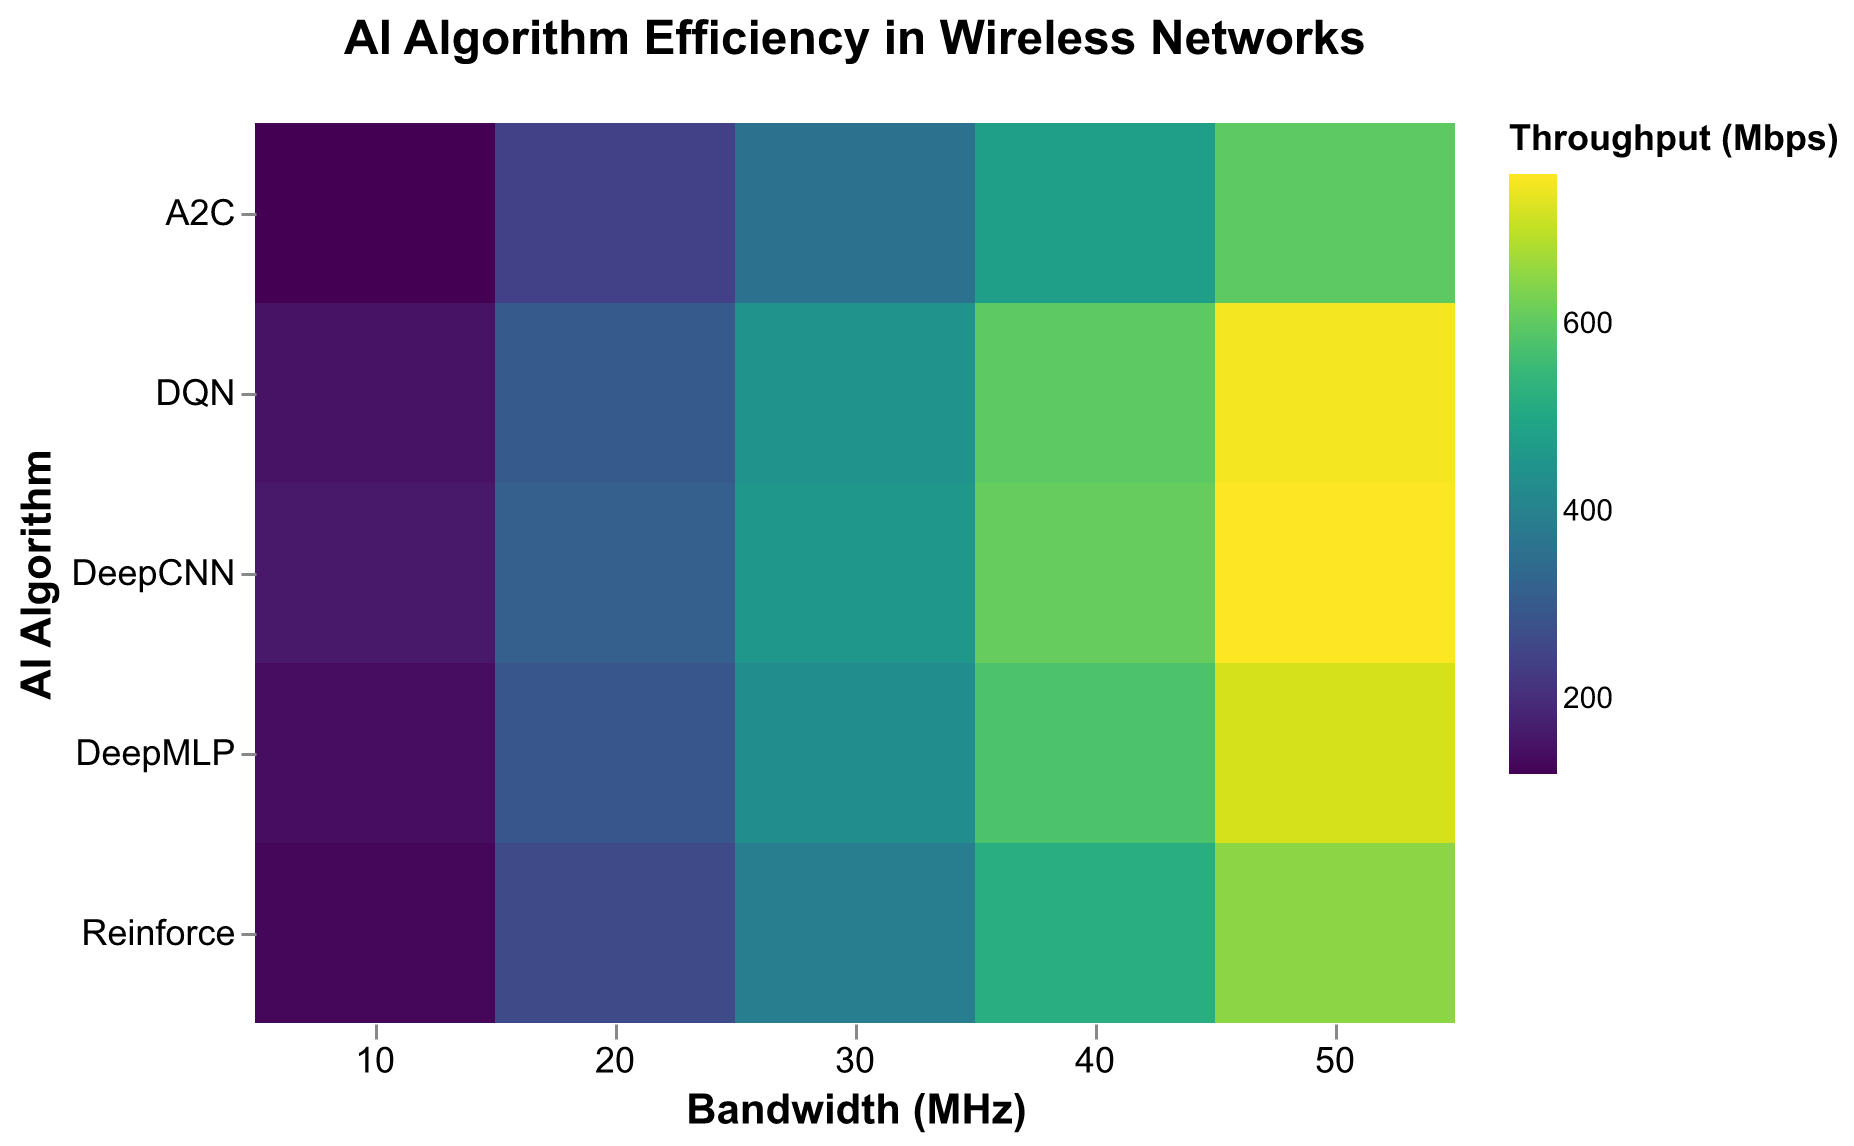What is the title of the heatmap? The title is usually displayed at the top of the plot and gives an overview of what the figure represents.
Answer: AI Algorithm Efficiency in Wireless Networks Which AI algorithm has the highest throughput at 50 MHz bandwidth? Look for the 50 MHz bandwidth column and identify the algorithm with the darkest color, which represents the highest throughput.
Answer: DeepCNN What are the axis labels for the x and y axes? The x-axis label is usually found at the bottom of the axis, and the y-axis label is found at the side. These labels describe what the respective axes represent.
Answer: Bandwidth (MHz) and AI Algorithm How does the throughput change for the algorithm DeepMLP as the bandwidth increases from 10 MHz to 50 MHz? Observe the color changes across the row corresponding to DeepMLP from the 10 MHz to the 50 MHz column. The increase in throughput is indicated by a shift towards darker colors.
Answer: Increases Which algorithm shows the lowest throughput at the lowest bandwidth? Identify the lowest throughput in the 10 MHz column by finding the lightest color and note the corresponding algorithm.
Answer: A2C Compare the throughput of DQN and Reinforce algorithms at 30 MHz bandwidth. Which one is higher? Check the colors for the 30 MHz column under both DQN and Reinforce rows. The darker color represents higher throughput.
Answer: DQN What is the throughput value for DeepCNN at 40 MHz? Identify the color for the intersection of DeepCNN and 40 MHz, then use the color legend to find the corresponding throughput value.
Answer: 610 Mbps Is there a general trend in the throughput as bandwidth increases for any algorithm? Examine the color gradient in each row, from left (lower bandwidth) to right (higher bandwidth). The trend is indicated by a shift from lighter to darker colors.
Answer: Yes, increases Which algorithm has the most consistent throughput increase across different bandwidth allocations? Compare the color gradients across the rows for each algorithm to see which one shows the most linear transition from light to dark.
Answer: DeepCNN Among all the algorithms, which one exhibits the highest throughput at any bandwidth? Look for the darkest cell in the entire heatmap and note the corresponding algorithm and bandwidth.
Answer: DeepCNN at 50 MHz 